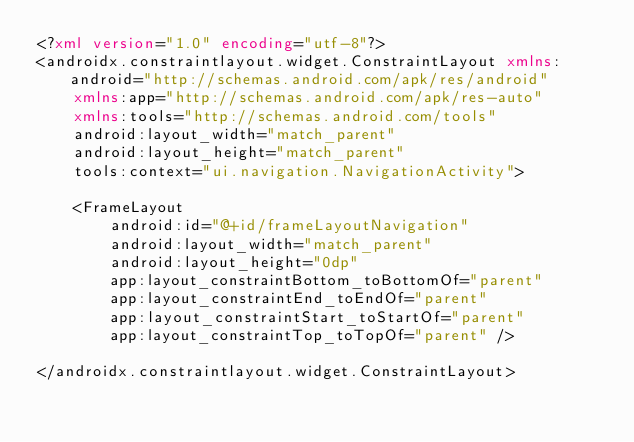Convert code to text. <code><loc_0><loc_0><loc_500><loc_500><_XML_><?xml version="1.0" encoding="utf-8"?>
<androidx.constraintlayout.widget.ConstraintLayout xmlns:android="http://schemas.android.com/apk/res/android"
    xmlns:app="http://schemas.android.com/apk/res-auto"
    xmlns:tools="http://schemas.android.com/tools"
    android:layout_width="match_parent"
    android:layout_height="match_parent"
    tools:context="ui.navigation.NavigationActivity">

    <FrameLayout
        android:id="@+id/frameLayoutNavigation"
        android:layout_width="match_parent"
        android:layout_height="0dp"
        app:layout_constraintBottom_toBottomOf="parent"
        app:layout_constraintEnd_toEndOf="parent"
        app:layout_constraintStart_toStartOf="parent"
        app:layout_constraintTop_toTopOf="parent" />

</androidx.constraintlayout.widget.ConstraintLayout></code> 